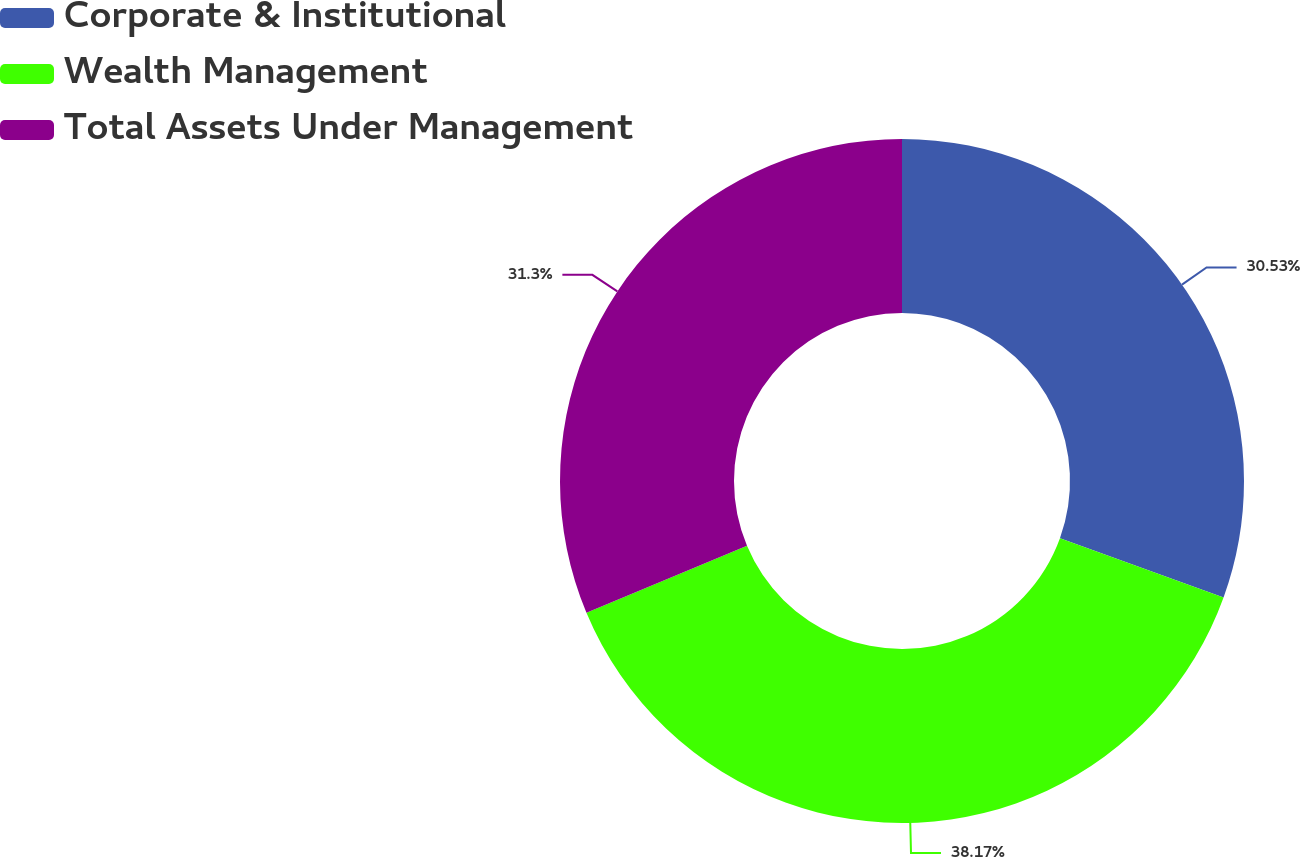<chart> <loc_0><loc_0><loc_500><loc_500><pie_chart><fcel>Corporate & Institutional<fcel>Wealth Management<fcel>Total Assets Under Management<nl><fcel>30.53%<fcel>38.17%<fcel>31.3%<nl></chart> 